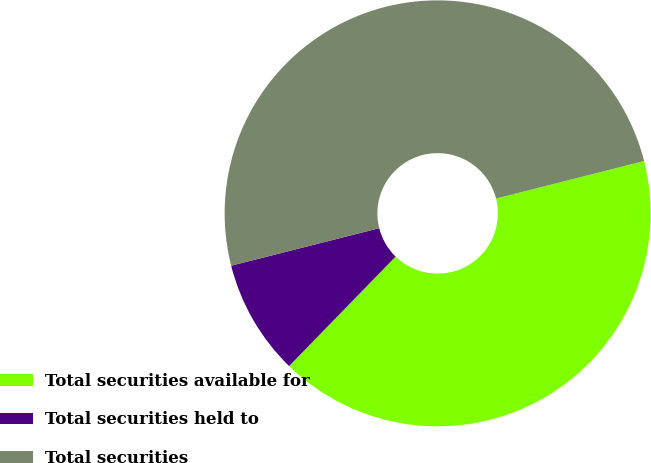Convert chart to OTSL. <chart><loc_0><loc_0><loc_500><loc_500><pie_chart><fcel>Total securities available for<fcel>Total securities held to<fcel>Total securities<nl><fcel>41.23%<fcel>8.77%<fcel>50.0%<nl></chart> 